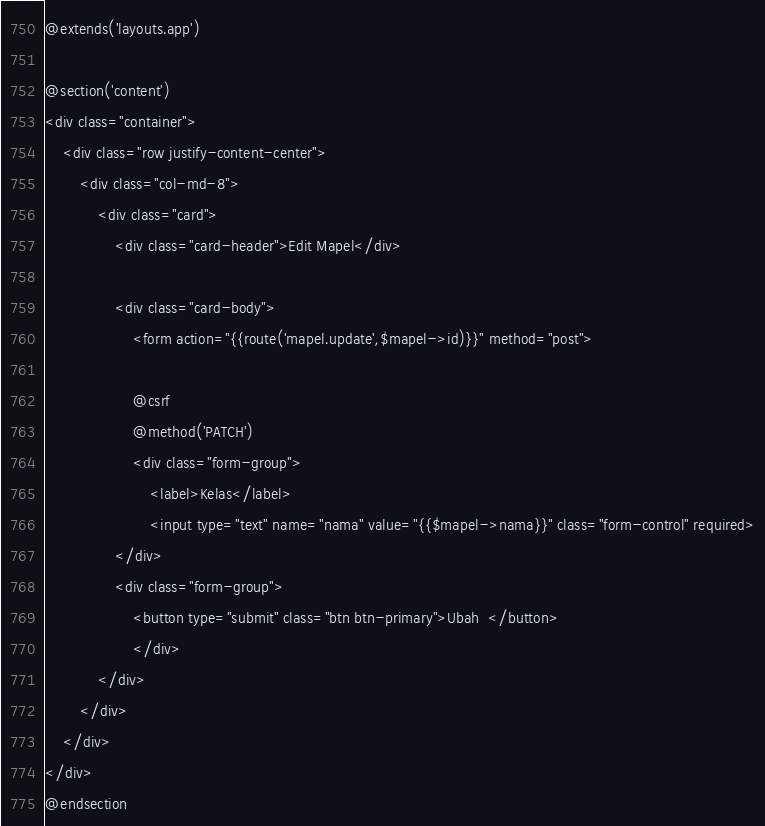Convert code to text. <code><loc_0><loc_0><loc_500><loc_500><_PHP_>@extends('layouts.app')

@section('content')
<div class="container">
    <div class="row justify-content-center">
        <div class="col-md-8">
            <div class="card">
                <div class="card-header">Edit Mapel</div>

                <div class="card-body">
                    <form action="{{route('mapel.update',$mapel->id)}}" method="post">
                
                    @csrf
                    @method('PATCH')
                    <div class="form-group">
                        <label>Kelas</label>
                        <input type="text" name="nama" value="{{$mapel->nama}}" class="form-control" required>
                </div>
                <div class="form-group">
                    <button type="submit" class="btn btn-primary">Ubah  </button>
                    </div>
            </div>
        </div>
    </div>
</div>
@endsection
</code> 